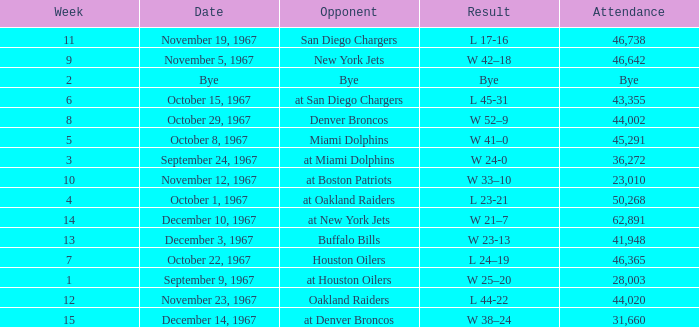Would you mind parsing the complete table? {'header': ['Week', 'Date', 'Opponent', 'Result', 'Attendance'], 'rows': [['11', 'November 19, 1967', 'San Diego Chargers', 'L 17-16', '46,738'], ['9', 'November 5, 1967', 'New York Jets', 'W 42–18', '46,642'], ['2', 'Bye', 'Bye', 'Bye', 'Bye'], ['6', 'October 15, 1967', 'at San Diego Chargers', 'L 45-31', '43,355'], ['8', 'October 29, 1967', 'Denver Broncos', 'W 52–9', '44,002'], ['5', 'October 8, 1967', 'Miami Dolphins', 'W 41–0', '45,291'], ['3', 'September 24, 1967', 'at Miami Dolphins', 'W 24-0', '36,272'], ['10', 'November 12, 1967', 'at Boston Patriots', 'W 33–10', '23,010'], ['4', 'October 1, 1967', 'at Oakland Raiders', 'L 23-21', '50,268'], ['14', 'December 10, 1967', 'at New York Jets', 'W 21–7', '62,891'], ['13', 'December 3, 1967', 'Buffalo Bills', 'W 23-13', '41,948'], ['7', 'October 22, 1967', 'Houston Oilers', 'L 24–19', '46,365'], ['1', 'September 9, 1967', 'at Houston Oilers', 'W 25–20', '28,003'], ['12', 'November 23, 1967', 'Oakland Raiders', 'L 44-22', '44,020'], ['15', 'December 14, 1967', 'at Denver Broncos', 'W 38–24', '31,660']]} Which week was the game on December 14, 1967? 15.0. 